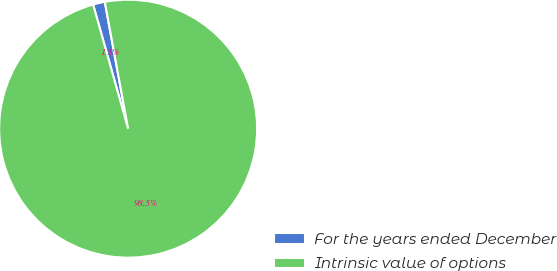Convert chart to OTSL. <chart><loc_0><loc_0><loc_500><loc_500><pie_chart><fcel>For the years ended December<fcel>Intrinsic value of options<nl><fcel>1.48%<fcel>98.52%<nl></chart> 